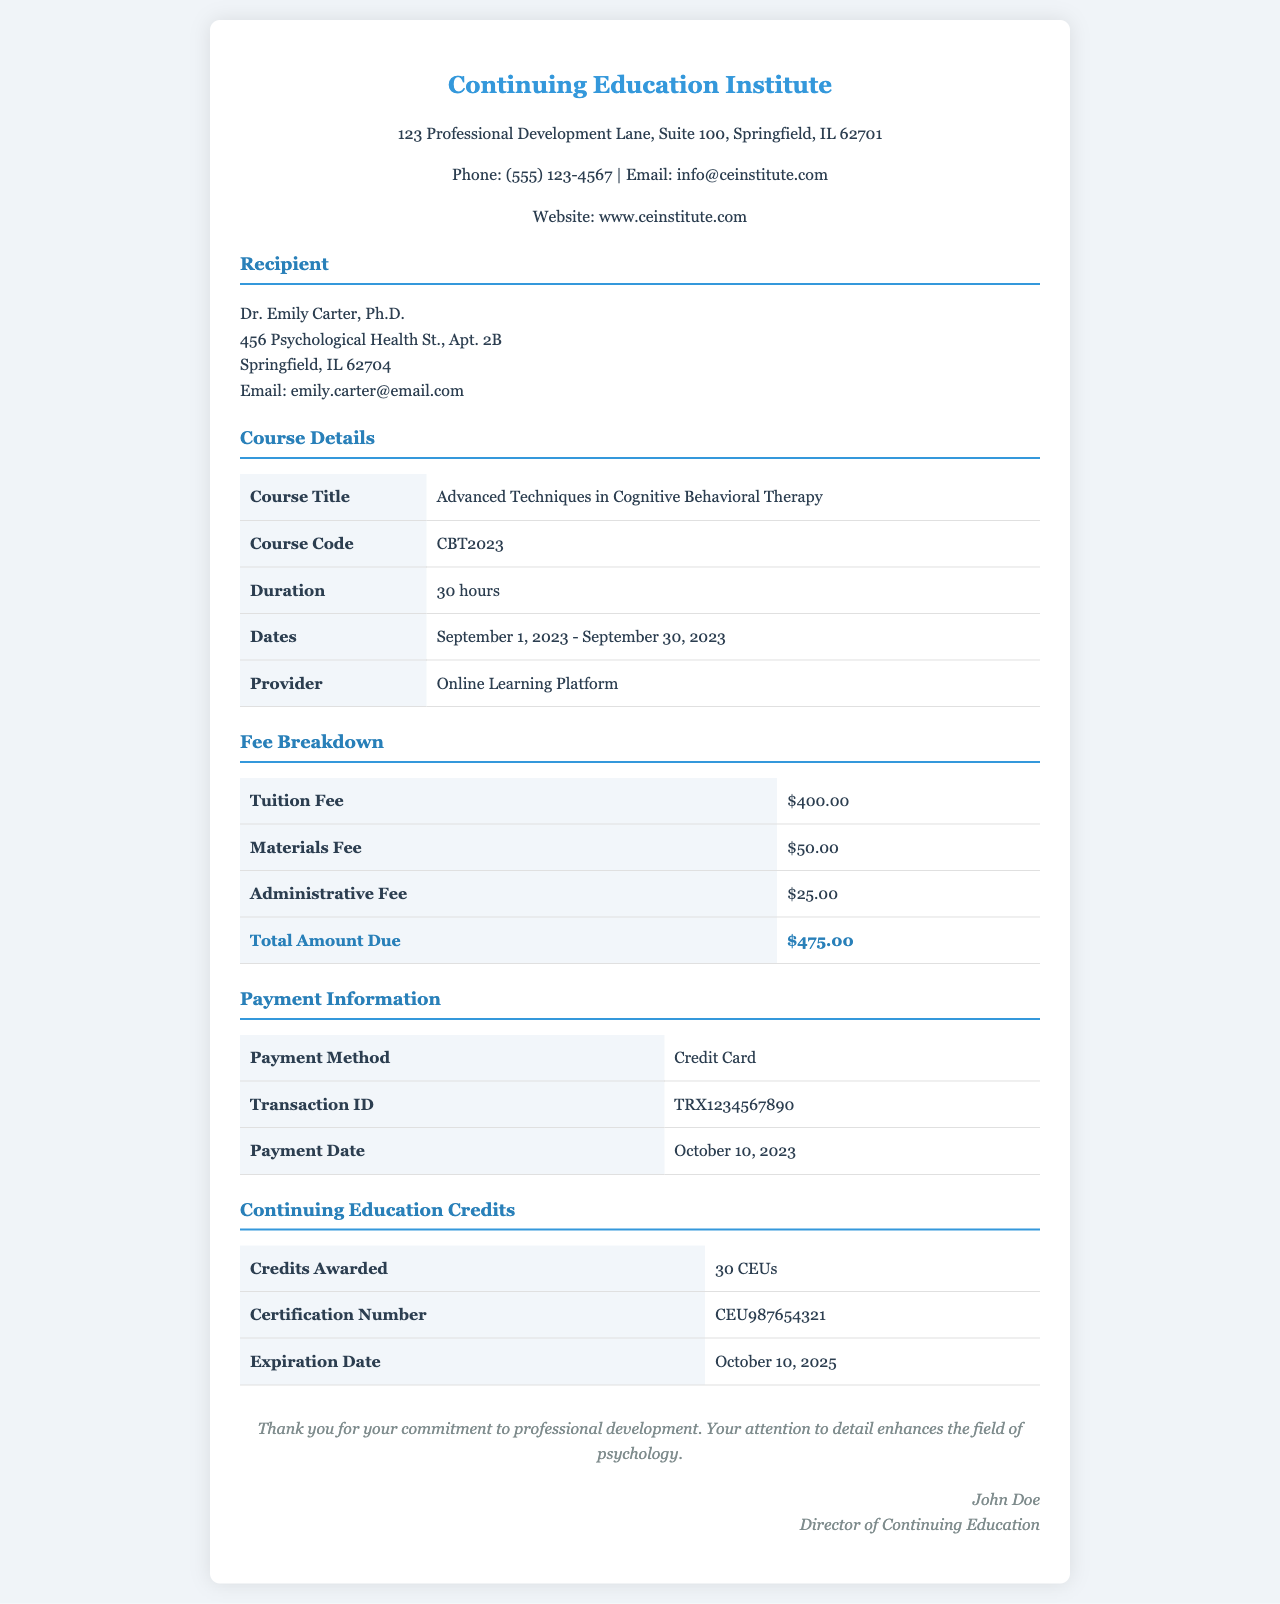What is the recipient's name? The recipient's name is provided in the document under the recipient section.
Answer: Dr. Emily Carter, Ph.D What is the total amount due? The total amount due is displayed in the fee breakdown section as the total of all fees.
Answer: $475.00 What is the course duration? The course duration is listed in the course details section of the document.
Answer: 30 hours What is the payment method? The payment method is mentioned in the payment information section of the receipt.
Answer: Credit Card What are the continuing education credits awarded? The credits awarded are specified in the continuing education credits section of the document.
Answer: 30 CEUs What is the expiration date of the certification number? The expiration date can be found in the continuing education credits section and indicates how long the credits are valid.
Answer: October 10, 2025 What was the payment date? The payment date can be found in the payment information section of the document.
Answer: October 10, 2023 What is the course title? The course title is provided in the course details section as the main focus of the continuing education credits.
Answer: Advanced Techniques in Cognitive Behavioral Therapy What is the materials fee? The materials fee is listed in the fee breakdown section with a specific monetary value.
Answer: $50.00 